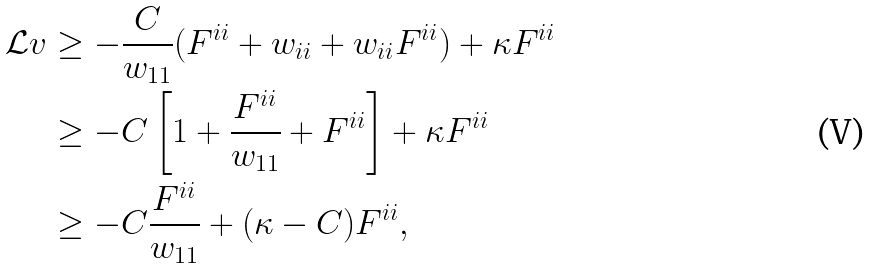Convert formula to latex. <formula><loc_0><loc_0><loc_500><loc_500>\mathcal { L } v & \geq - \frac { C } { w _ { 1 1 } } ( F ^ { i i } + w _ { i i } + w _ { i i } F ^ { i i } ) + \kappa F ^ { i i } \\ & \geq - C \left [ 1 + \frac { F ^ { i i } } { w _ { 1 1 } } + F ^ { i i } \right ] + \kappa F ^ { i i } \\ & \geq - C \frac { F ^ { i i } } { w _ { 1 1 } } + ( \kappa - C ) F ^ { i i } ,</formula> 